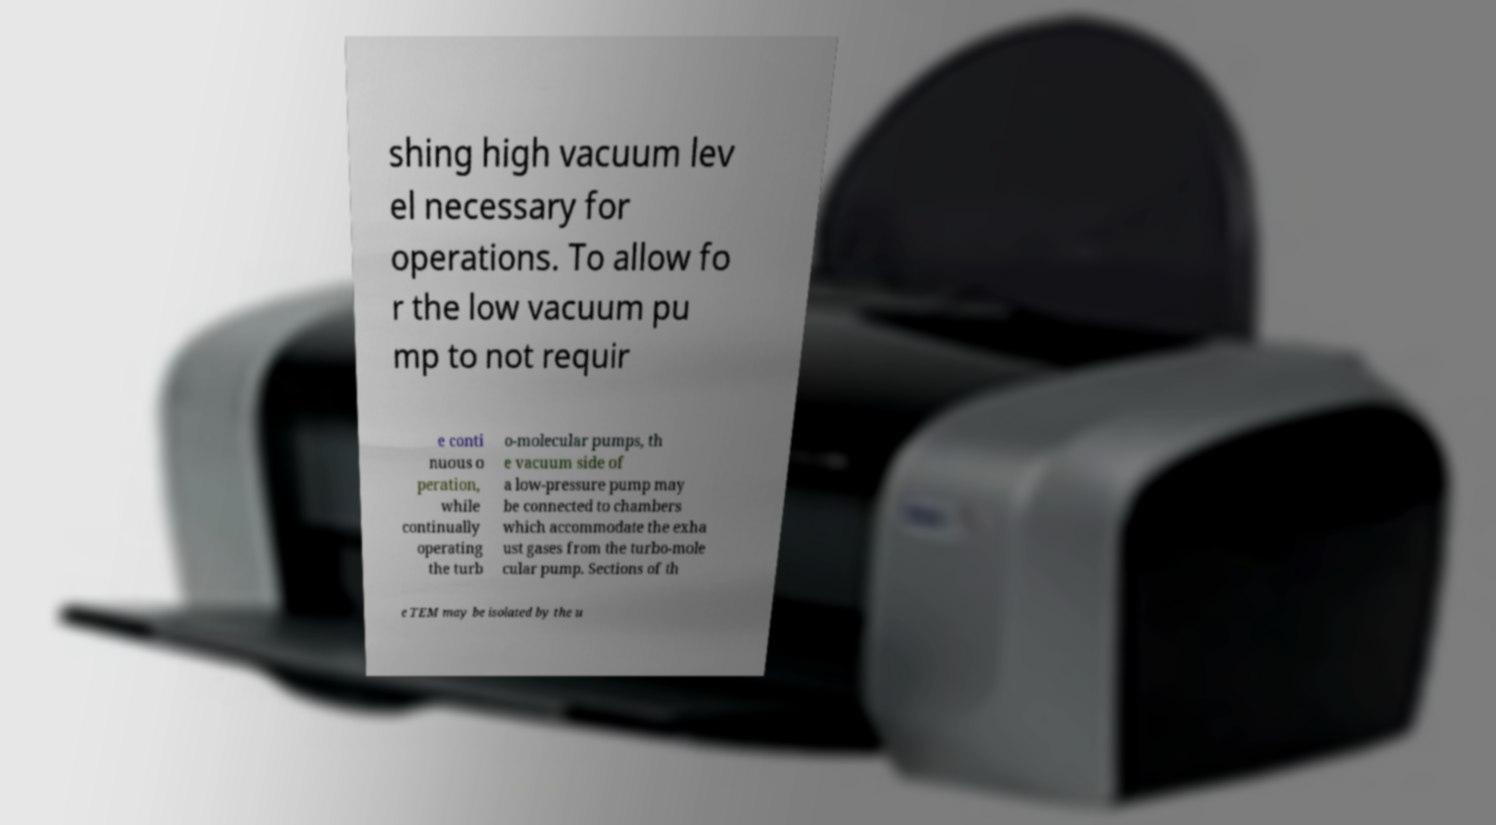What messages or text are displayed in this image? I need them in a readable, typed format. shing high vacuum lev el necessary for operations. To allow fo r the low vacuum pu mp to not requir e conti nuous o peration, while continually operating the turb o-molecular pumps, th e vacuum side of a low-pressure pump may be connected to chambers which accommodate the exha ust gases from the turbo-mole cular pump. Sections of th e TEM may be isolated by the u 